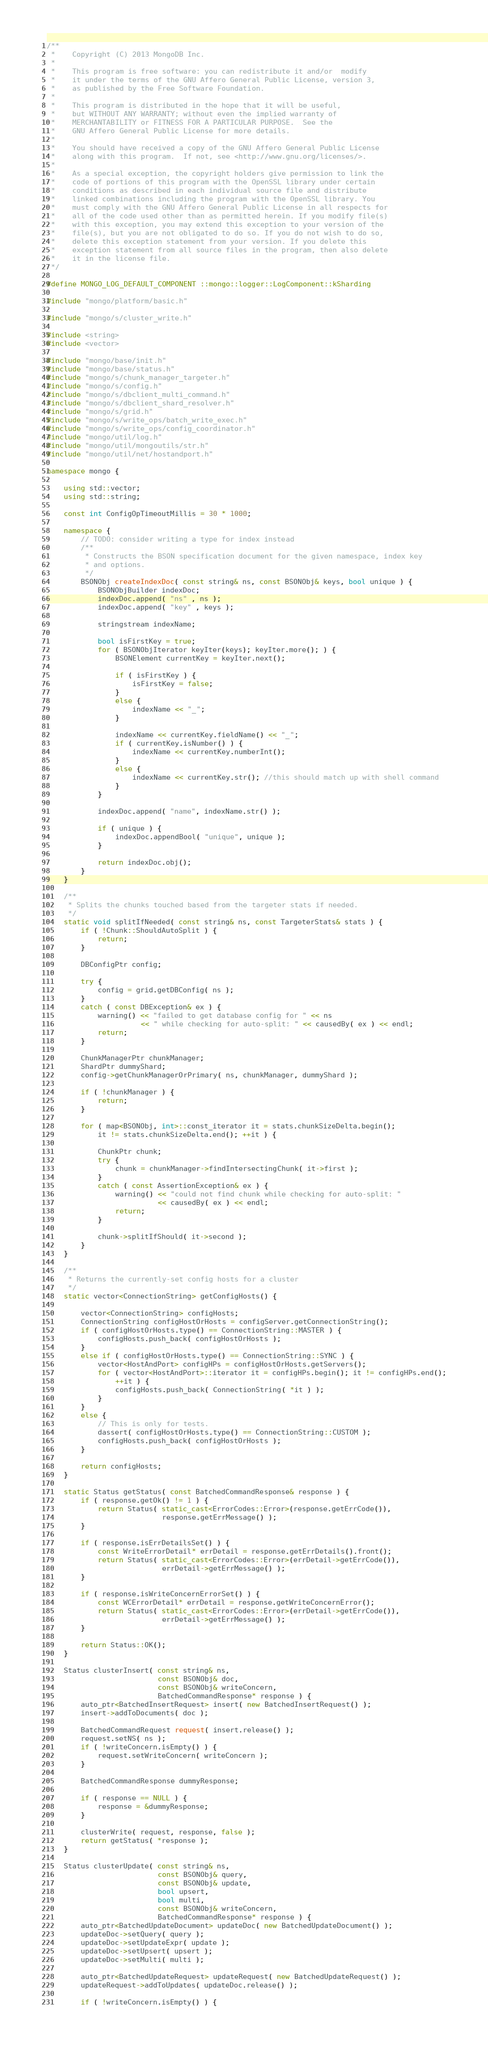<code> <loc_0><loc_0><loc_500><loc_500><_C++_>/**
 *    Copyright (C) 2013 MongoDB Inc.
 *
 *    This program is free software: you can redistribute it and/or  modify
 *    it under the terms of the GNU Affero General Public License, version 3,
 *    as published by the Free Software Foundation.
 *
 *    This program is distributed in the hope that it will be useful,
 *    but WITHOUT ANY WARRANTY; without even the implied warranty of
 *    MERCHANTABILITY or FITNESS FOR A PARTICULAR PURPOSE.  See the
 *    GNU Affero General Public License for more details.
 *
 *    You should have received a copy of the GNU Affero General Public License
 *    along with this program.  If not, see <http://www.gnu.org/licenses/>.
 *
 *    As a special exception, the copyright holders give permission to link the
 *    code of portions of this program with the OpenSSL library under certain
 *    conditions as described in each individual source file and distribute
 *    linked combinations including the program with the OpenSSL library. You
 *    must comply with the GNU Affero General Public License in all respects for
 *    all of the code used other than as permitted herein. If you modify file(s)
 *    with this exception, you may extend this exception to your version of the
 *    file(s), but you are not obligated to do so. If you do not wish to do so,
 *    delete this exception statement from your version. If you delete this
 *    exception statement from all source files in the program, then also delete
 *    it in the license file.
 */

#define MONGO_LOG_DEFAULT_COMPONENT ::mongo::logger::LogComponent::kSharding

#include "mongo/platform/basic.h"

#include "mongo/s/cluster_write.h"

#include <string>
#include <vector>

#include "mongo/base/init.h"
#include "mongo/base/status.h"
#include "mongo/s/chunk_manager_targeter.h"
#include "mongo/s/config.h"
#include "mongo/s/dbclient_multi_command.h"
#include "mongo/s/dbclient_shard_resolver.h"
#include "mongo/s/grid.h"
#include "mongo/s/write_ops/batch_write_exec.h"
#include "mongo/s/write_ops/config_coordinator.h"
#include "mongo/util/log.h"
#include "mongo/util/mongoutils/str.h"
#include "mongo/util/net/hostandport.h"

namespace mongo {

    using std::vector;
    using std::string;

    const int ConfigOpTimeoutMillis = 30 * 1000;

    namespace {
        // TODO: consider writing a type for index instead
        /**
         * Constructs the BSON specification document for the given namespace, index key
         * and options.
         */
        BSONObj createIndexDoc( const string& ns, const BSONObj& keys, bool unique ) {
            BSONObjBuilder indexDoc;
            indexDoc.append( "ns" , ns );
            indexDoc.append( "key" , keys );

            stringstream indexName;

            bool isFirstKey = true;
            for ( BSONObjIterator keyIter(keys); keyIter.more(); ) {
                BSONElement currentKey = keyIter.next();

                if ( isFirstKey ) {
                    isFirstKey = false;
                }
                else {
                    indexName << "_";
                }

                indexName << currentKey.fieldName() << "_";
                if ( currentKey.isNumber() ) {
                    indexName << currentKey.numberInt();
                }
                else {
                    indexName << currentKey.str(); //this should match up with shell command
                }
            }

            indexDoc.append( "name", indexName.str() );

            if ( unique ) {
                indexDoc.appendBool( "unique", unique );
            }

            return indexDoc.obj();
        }
    }

    /**
     * Splits the chunks touched based from the targeter stats if needed.
     */
    static void splitIfNeeded( const string& ns, const TargeterStats& stats ) {
        if ( !Chunk::ShouldAutoSplit ) {
            return;
        }

        DBConfigPtr config;

        try {
            config = grid.getDBConfig( ns );
        }
        catch ( const DBException& ex ) {
            warning() << "failed to get database config for " << ns
                      << " while checking for auto-split: " << causedBy( ex ) << endl;
            return;
        }

        ChunkManagerPtr chunkManager;
        ShardPtr dummyShard;
        config->getChunkManagerOrPrimary( ns, chunkManager, dummyShard );

        if ( !chunkManager ) {
            return;
        }

        for ( map<BSONObj, int>::const_iterator it = stats.chunkSizeDelta.begin();
            it != stats.chunkSizeDelta.end(); ++it ) {

            ChunkPtr chunk;
            try {
                chunk = chunkManager->findIntersectingChunk( it->first );
            }
            catch ( const AssertionException& ex ) {
                warning() << "could not find chunk while checking for auto-split: "
                          << causedBy( ex ) << endl;
                return;
            }

            chunk->splitIfShould( it->second );
        }
    }

    /**
     * Returns the currently-set config hosts for a cluster
     */
    static vector<ConnectionString> getConfigHosts() {

        vector<ConnectionString> configHosts;
        ConnectionString configHostOrHosts = configServer.getConnectionString();
        if ( configHostOrHosts.type() == ConnectionString::MASTER ) {
            configHosts.push_back( configHostOrHosts );
        }
        else if ( configHostOrHosts.type() == ConnectionString::SYNC ) {
            vector<HostAndPort> configHPs = configHostOrHosts.getServers();
            for ( vector<HostAndPort>::iterator it = configHPs.begin(); it != configHPs.end();
                ++it ) {
                configHosts.push_back( ConnectionString( *it ) );
            }
        }
        else {
            // This is only for tests.
            dassert( configHostOrHosts.type() == ConnectionString::CUSTOM );
            configHosts.push_back( configHostOrHosts );
        }

        return configHosts;
    }

    static Status getStatus( const BatchedCommandResponse& response ) {
        if ( response.getOk() != 1 ) {
            return Status( static_cast<ErrorCodes::Error>(response.getErrCode()),
                           response.getErrMessage() );
        }

        if ( response.isErrDetailsSet() ) {
            const WriteErrorDetail* errDetail = response.getErrDetails().front();
            return Status( static_cast<ErrorCodes::Error>(errDetail->getErrCode()),
                           errDetail->getErrMessage() );
        }

        if ( response.isWriteConcernErrorSet() ) {
            const WCErrorDetail* errDetail = response.getWriteConcernError();
            return Status( static_cast<ErrorCodes::Error>(errDetail->getErrCode()),
                           errDetail->getErrMessage() );
        }

        return Status::OK();
    }

    Status clusterInsert( const string& ns,
                          const BSONObj& doc,
                          const BSONObj& writeConcern,
                          BatchedCommandResponse* response ) {
        auto_ptr<BatchedInsertRequest> insert( new BatchedInsertRequest() );
        insert->addToDocuments( doc );

        BatchedCommandRequest request( insert.release() );
        request.setNS( ns );
        if ( !writeConcern.isEmpty() ) {
            request.setWriteConcern( writeConcern );
        }

        BatchedCommandResponse dummyResponse;

        if ( response == NULL ) {
            response = &dummyResponse;
        }

        clusterWrite( request, response, false );
        return getStatus( *response );
    }

    Status clusterUpdate( const string& ns,
                          const BSONObj& query,
                          const BSONObj& update,
                          bool upsert,
                          bool multi,
                          const BSONObj& writeConcern,
                          BatchedCommandResponse* response ) {
        auto_ptr<BatchedUpdateDocument> updateDoc( new BatchedUpdateDocument() );
        updateDoc->setQuery( query );
        updateDoc->setUpdateExpr( update );
        updateDoc->setUpsert( upsert );
        updateDoc->setMulti( multi );

        auto_ptr<BatchedUpdateRequest> updateRequest( new BatchedUpdateRequest() );
        updateRequest->addToUpdates( updateDoc.release() );

        if ( !writeConcern.isEmpty() ) {</code> 